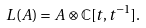Convert formula to latex. <formula><loc_0><loc_0><loc_500><loc_500>L ( A ) = A \otimes \mathbb { C } [ t , t ^ { - 1 } ] .</formula> 